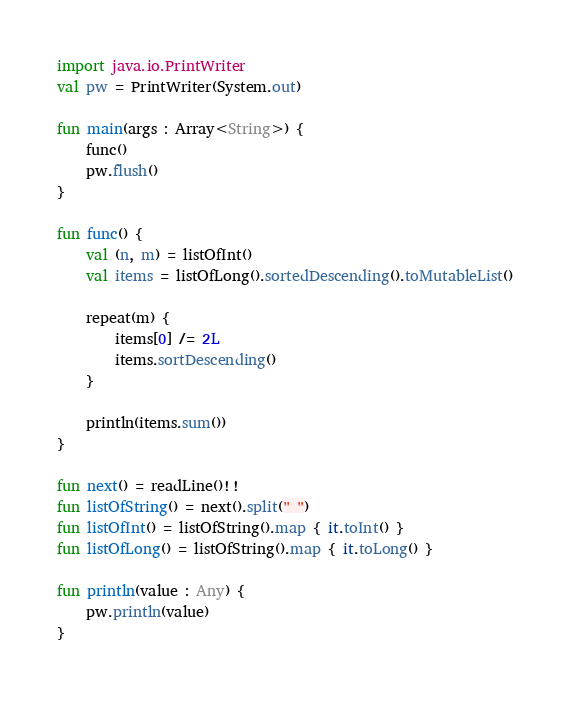<code> <loc_0><loc_0><loc_500><loc_500><_Kotlin_>import java.io.PrintWriter
val pw = PrintWriter(System.out)

fun main(args : Array<String>) {
    func()
    pw.flush()
}

fun func() {
    val (n, m) = listOfInt()
    val items = listOfLong().sortedDescending().toMutableList()

    repeat(m) {
        items[0] /= 2L
        items.sortDescending()
    }

    println(items.sum())
}

fun next() = readLine()!!
fun listOfString() = next().split(" ")
fun listOfInt() = listOfString().map { it.toInt() }
fun listOfLong() = listOfString().map { it.toLong() }

fun println(value : Any) {
    pw.println(value)
}</code> 